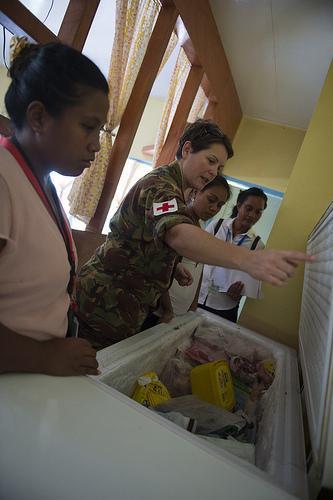How many people looking in the freezer?
Give a very brief answer. 4. How many people are wearing camouflage?
Give a very brief answer. 1. 